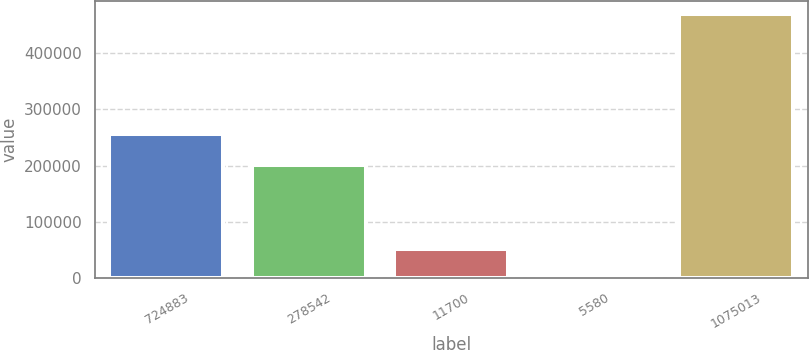Convert chart. <chart><loc_0><loc_0><loc_500><loc_500><bar_chart><fcel>724883<fcel>278542<fcel>11700<fcel>5580<fcel>1075013<nl><fcel>255460<fcel>200331<fcel>51638.2<fcel>5302<fcel>468664<nl></chart> 